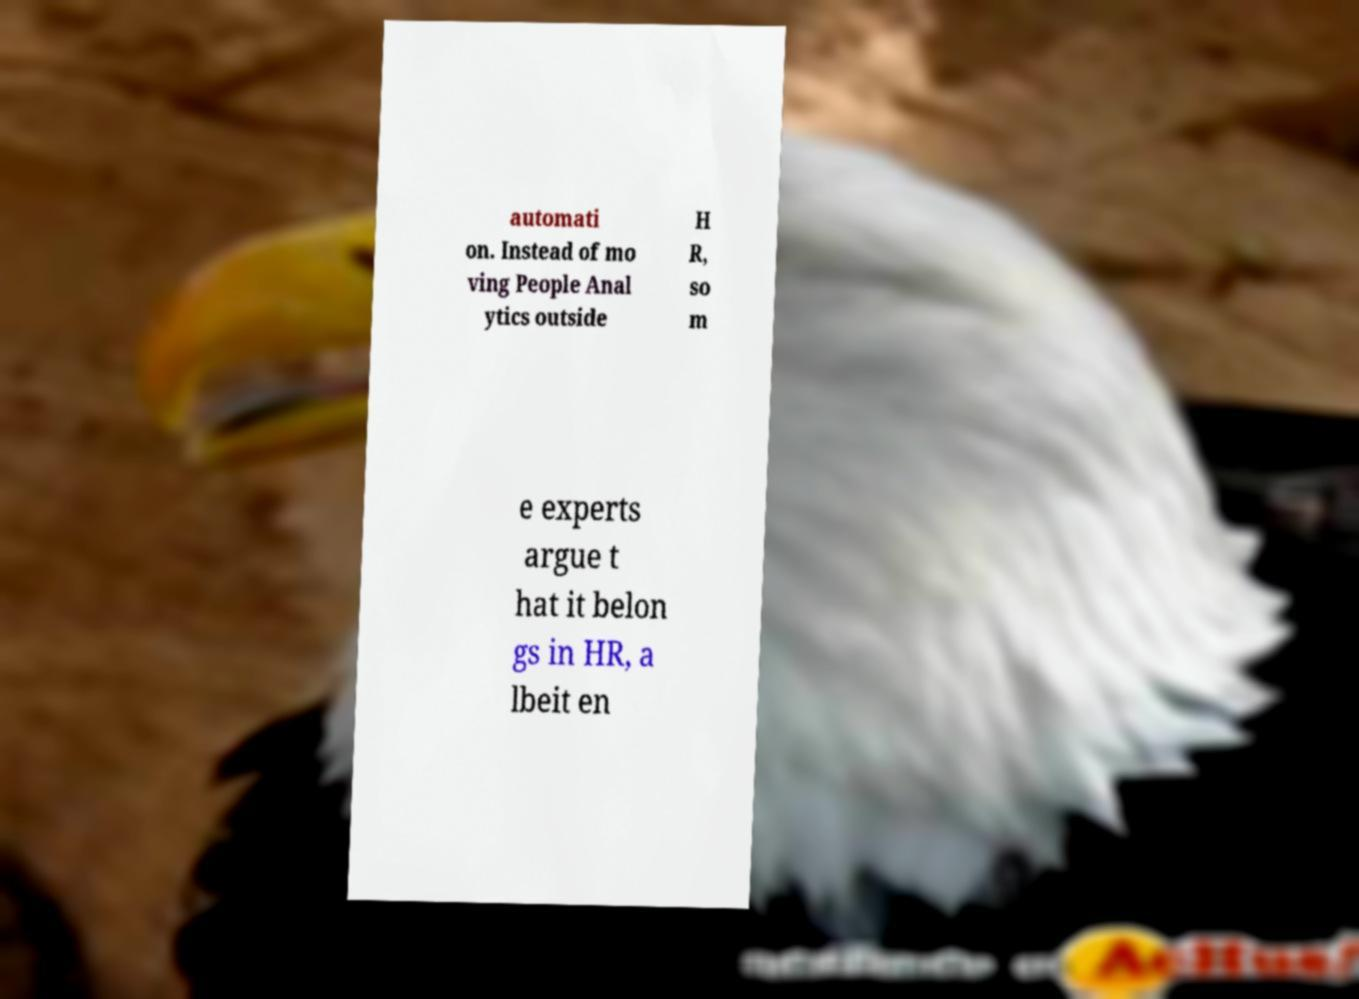Could you extract and type out the text from this image? automati on. Instead of mo ving People Anal ytics outside H R, so m e experts argue t hat it belon gs in HR, a lbeit en 